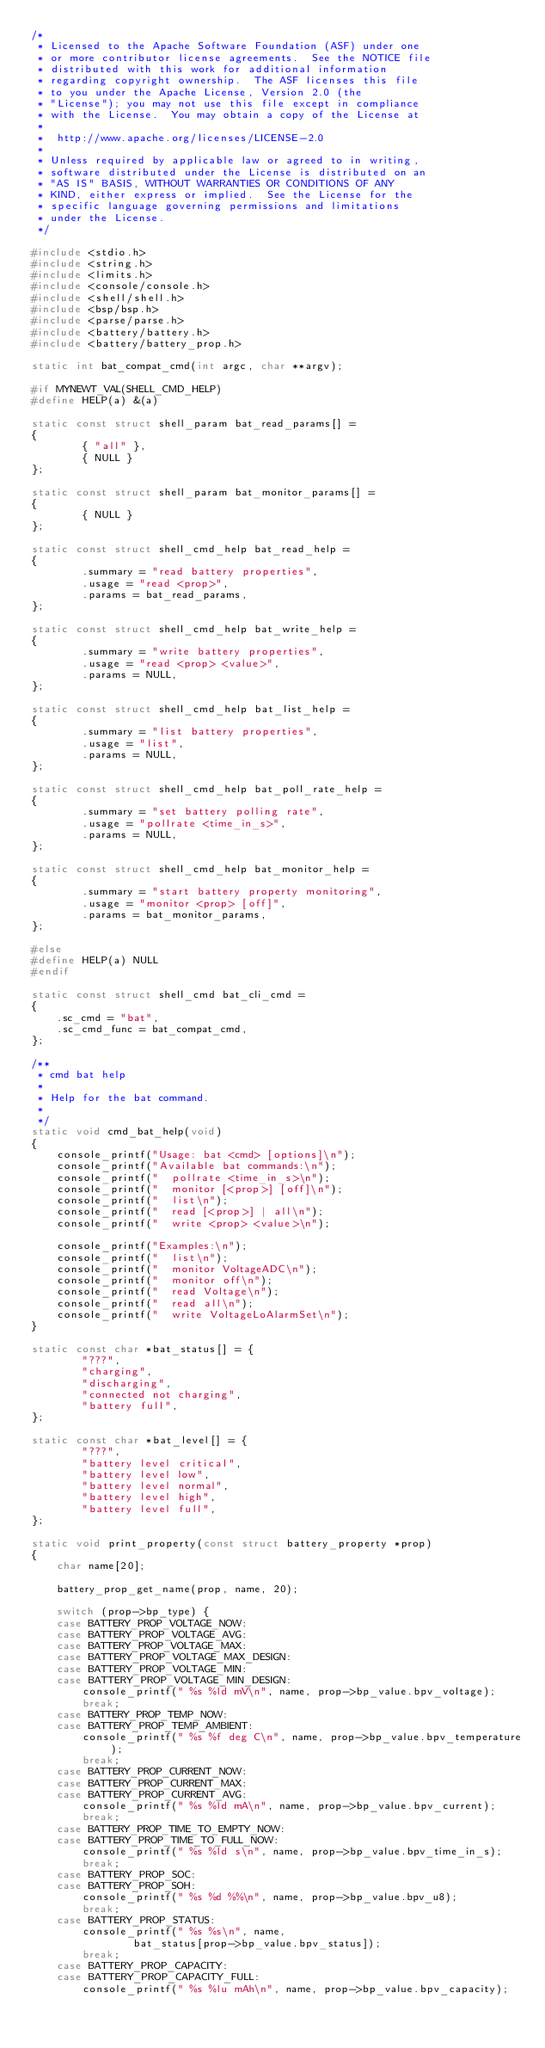<code> <loc_0><loc_0><loc_500><loc_500><_C_>/*
 * Licensed to the Apache Software Foundation (ASF) under one
 * or more contributor license agreements.  See the NOTICE file
 * distributed with this work for additional information
 * regarding copyright ownership.  The ASF licenses this file
 * to you under the Apache License, Version 2.0 (the
 * "License"); you may not use this file except in compliance
 * with the License.  You may obtain a copy of the License at
 *
 *  http://www.apache.org/licenses/LICENSE-2.0
 *
 * Unless required by applicable law or agreed to in writing,
 * software distributed under the License is distributed on an
 * "AS IS" BASIS, WITHOUT WARRANTIES OR CONDITIONS OF ANY
 * KIND, either express or implied.  See the License for the
 * specific language governing permissions and limitations
 * under the License.
 */

#include <stdio.h>
#include <string.h>
#include <limits.h>
#include <console/console.h>
#include <shell/shell.h>
#include <bsp/bsp.h>
#include <parse/parse.h>
#include <battery/battery.h>
#include <battery/battery_prop.h>

static int bat_compat_cmd(int argc, char **argv);

#if MYNEWT_VAL(SHELL_CMD_HELP)
#define HELP(a) &(a)

static const struct shell_param bat_read_params[] =
{
        { "all" },
        { NULL }
};

static const struct shell_param bat_monitor_params[] =
{
        { NULL }
};

static const struct shell_cmd_help bat_read_help =
{
        .summary = "read battery properties",
        .usage = "read <prop>",
        .params = bat_read_params,
};

static const struct shell_cmd_help bat_write_help =
{
        .summary = "write battery properties",
        .usage = "read <prop> <value>",
        .params = NULL,
};

static const struct shell_cmd_help bat_list_help =
{
        .summary = "list battery properties",
        .usage = "list",
        .params = NULL,
};

static const struct shell_cmd_help bat_poll_rate_help =
{
        .summary = "set battery polling rate",
        .usage = "pollrate <time_in_s>",
        .params = NULL,
};

static const struct shell_cmd_help bat_monitor_help =
{
        .summary = "start battery property monitoring",
        .usage = "monitor <prop> [off]",
        .params = bat_monitor_params,
};

#else
#define HELP(a) NULL
#endif

static const struct shell_cmd bat_cli_cmd =
{
    .sc_cmd = "bat",
    .sc_cmd_func = bat_compat_cmd,
};

/**
 * cmd bat help
 *
 * Help for the bat command.
 *
 */
static void cmd_bat_help(void)
{
    console_printf("Usage: bat <cmd> [options]\n");
    console_printf("Available bat commands:\n");
    console_printf("  pollrate <time_in_s>\n");
    console_printf("  monitor [<prop>] [off]\n");
    console_printf("  list\n");
    console_printf("  read [<prop>] | all\n");
    console_printf("  write <prop> <value>\n");

    console_printf("Examples:\n");
    console_printf("  list\n");
    console_printf("  monitor VoltageADC\n");
    console_printf("  monitor off\n");
    console_printf("  read Voltage\n");
    console_printf("  read all\n");
    console_printf("  write VoltageLoAlarmSet\n");
}

static const char *bat_status[] = {
        "???",
        "charging",
        "discharging",
        "connected not charging",
        "battery full",
};

static const char *bat_level[] = {
        "???",
        "battery level critical",
        "battery level low",
        "battery level normal",
        "battery level high",
        "battery level full",
};

static void print_property(const struct battery_property *prop)
{
    char name[20];

    battery_prop_get_name(prop, name, 20);

    switch (prop->bp_type) {
    case BATTERY_PROP_VOLTAGE_NOW:
    case BATTERY_PROP_VOLTAGE_AVG:
    case BATTERY_PROP_VOLTAGE_MAX:
    case BATTERY_PROP_VOLTAGE_MAX_DESIGN:
    case BATTERY_PROP_VOLTAGE_MIN:
    case BATTERY_PROP_VOLTAGE_MIN_DESIGN:
        console_printf(" %s %ld mV\n", name, prop->bp_value.bpv_voltage);
        break;
    case BATTERY_PROP_TEMP_NOW:
    case BATTERY_PROP_TEMP_AMBIENT:
        console_printf(" %s %f deg C\n", name, prop->bp_value.bpv_temperature);
        break;
    case BATTERY_PROP_CURRENT_NOW:
    case BATTERY_PROP_CURRENT_MAX:
    case BATTERY_PROP_CURRENT_AVG:
        console_printf(" %s %ld mA\n", name, prop->bp_value.bpv_current);
        break;
    case BATTERY_PROP_TIME_TO_EMPTY_NOW:
    case BATTERY_PROP_TIME_TO_FULL_NOW:
        console_printf(" %s %ld s\n", name, prop->bp_value.bpv_time_in_s);
        break;
    case BATTERY_PROP_SOC:
    case BATTERY_PROP_SOH:
        console_printf(" %s %d %%\n", name, prop->bp_value.bpv_u8);
        break;
    case BATTERY_PROP_STATUS:
        console_printf(" %s %s\n", name,
                bat_status[prop->bp_value.bpv_status]);
        break;
    case BATTERY_PROP_CAPACITY:
    case BATTERY_PROP_CAPACITY_FULL:
        console_printf(" %s %lu mAh\n", name, prop->bp_value.bpv_capacity);</code> 